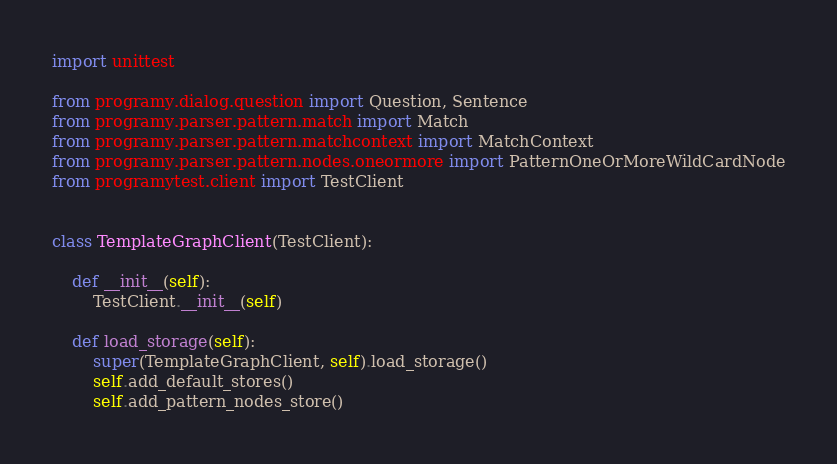<code> <loc_0><loc_0><loc_500><loc_500><_Python_>import unittest

from programy.dialog.question import Question, Sentence
from programy.parser.pattern.match import Match
from programy.parser.pattern.matchcontext import MatchContext
from programy.parser.pattern.nodes.oneormore import PatternOneOrMoreWildCardNode
from programytest.client import TestClient


class TemplateGraphClient(TestClient):

    def __init__(self):
        TestClient.__init__(self)

    def load_storage(self):
        super(TemplateGraphClient, self).load_storage()
        self.add_default_stores()
        self.add_pattern_nodes_store()</code> 